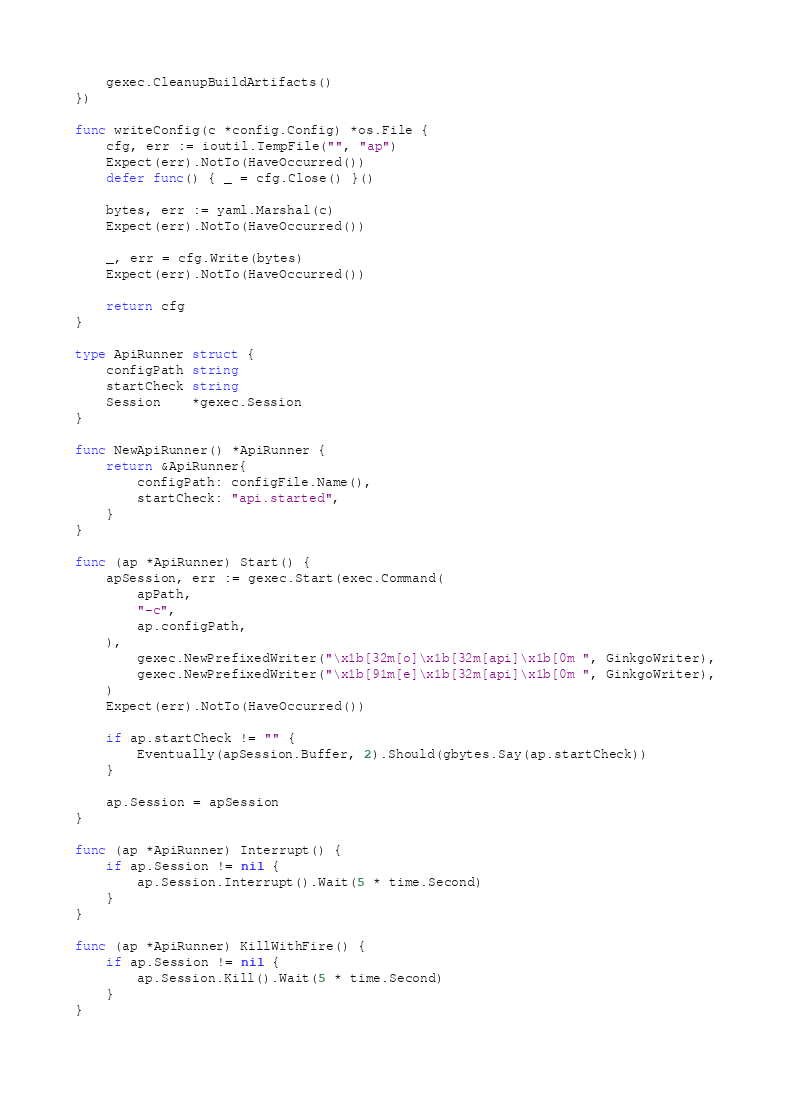<code> <loc_0><loc_0><loc_500><loc_500><_Go_>	gexec.CleanupBuildArtifacts()
})

func writeConfig(c *config.Config) *os.File {
	cfg, err := ioutil.TempFile("", "ap")
	Expect(err).NotTo(HaveOccurred())
	defer func() { _ = cfg.Close() }()

	bytes, err := yaml.Marshal(c)
	Expect(err).NotTo(HaveOccurred())

	_, err = cfg.Write(bytes)
	Expect(err).NotTo(HaveOccurred())

	return cfg
}

type ApiRunner struct {
	configPath string
	startCheck string
	Session    *gexec.Session
}

func NewApiRunner() *ApiRunner {
	return &ApiRunner{
		configPath: configFile.Name(),
		startCheck: "api.started",
	}
}

func (ap *ApiRunner) Start() {
	apSession, err := gexec.Start(exec.Command(
		apPath,
		"-c",
		ap.configPath,
	),
		gexec.NewPrefixedWriter("\x1b[32m[o]\x1b[32m[api]\x1b[0m ", GinkgoWriter),
		gexec.NewPrefixedWriter("\x1b[91m[e]\x1b[32m[api]\x1b[0m ", GinkgoWriter),
	)
	Expect(err).NotTo(HaveOccurred())

	if ap.startCheck != "" {
		Eventually(apSession.Buffer, 2).Should(gbytes.Say(ap.startCheck))
	}

	ap.Session = apSession
}

func (ap *ApiRunner) Interrupt() {
	if ap.Session != nil {
		ap.Session.Interrupt().Wait(5 * time.Second)
	}
}

func (ap *ApiRunner) KillWithFire() {
	if ap.Session != nil {
		ap.Session.Kill().Wait(5 * time.Second)
	}
}
</code> 